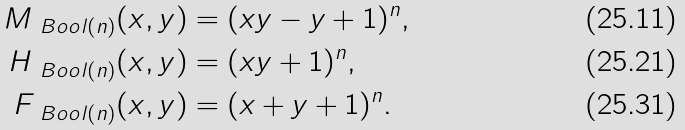Convert formula to latex. <formula><loc_0><loc_0><loc_500><loc_500>M _ { \ B o o l ( n ) } ( x , y ) & = ( x y - y + 1 ) ^ { n } , \\ H _ { \ B o o l ( n ) } ( x , y ) & = ( x y + 1 ) ^ { n } , \\ F _ { \ B o o l ( n ) } ( x , y ) & = ( x + y + 1 ) ^ { n } .</formula> 